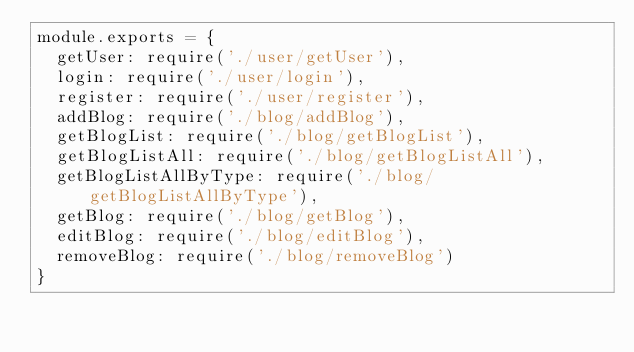Convert code to text. <code><loc_0><loc_0><loc_500><loc_500><_JavaScript_>module.exports = {
  getUser: require('./user/getUser'),
  login: require('./user/login'),
  register: require('./user/register'),
  addBlog: require('./blog/addBlog'),
  getBlogList: require('./blog/getBlogList'),
  getBlogListAll: require('./blog/getBlogListAll'),
  getBlogListAllByType: require('./blog/getBlogListAllByType'),
  getBlog: require('./blog/getBlog'),
  editBlog: require('./blog/editBlog'),
  removeBlog: require('./blog/removeBlog')
}
</code> 